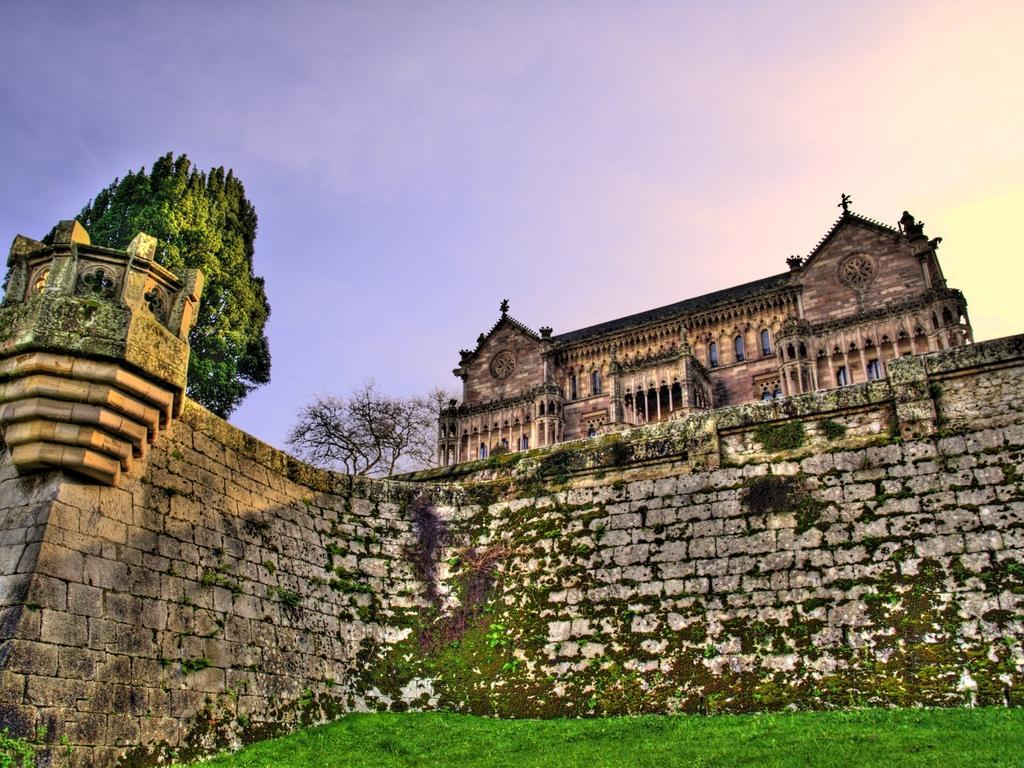Could you give a brief overview of what you see in this image? There is grass on the ground near a wall. In the background, there are trees, building which is having glass windows and there is blue sky. 